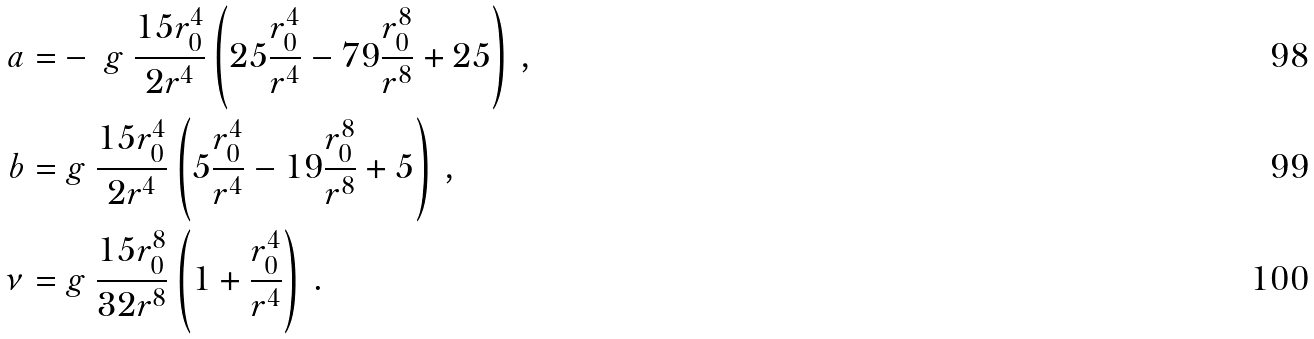<formula> <loc_0><loc_0><loc_500><loc_500>a = & - \ g \ \frac { 1 5 r _ { 0 } ^ { 4 } } { 2 r ^ { 4 } } \left ( 2 5 \frac { r _ { 0 } ^ { 4 } } { r ^ { 4 } } - 7 9 \frac { r _ { 0 } ^ { 8 } } { r ^ { 8 } } + 2 5 \right ) \, , \\ b = & \ g \ \frac { 1 5 r _ { 0 } ^ { 4 } } { 2 r ^ { 4 } } \left ( 5 \frac { r _ { 0 } ^ { 4 } } { r ^ { 4 } } - 1 9 \frac { r _ { 0 } ^ { 8 } } { r ^ { 8 } } + 5 \right ) \, , \\ \nu = & \ g \ \frac { 1 5 r _ { 0 } ^ { 8 } } { 3 2 r ^ { 8 } } \left ( 1 + \frac { r _ { 0 } ^ { 4 } } { r ^ { 4 } } \right ) \, .</formula> 